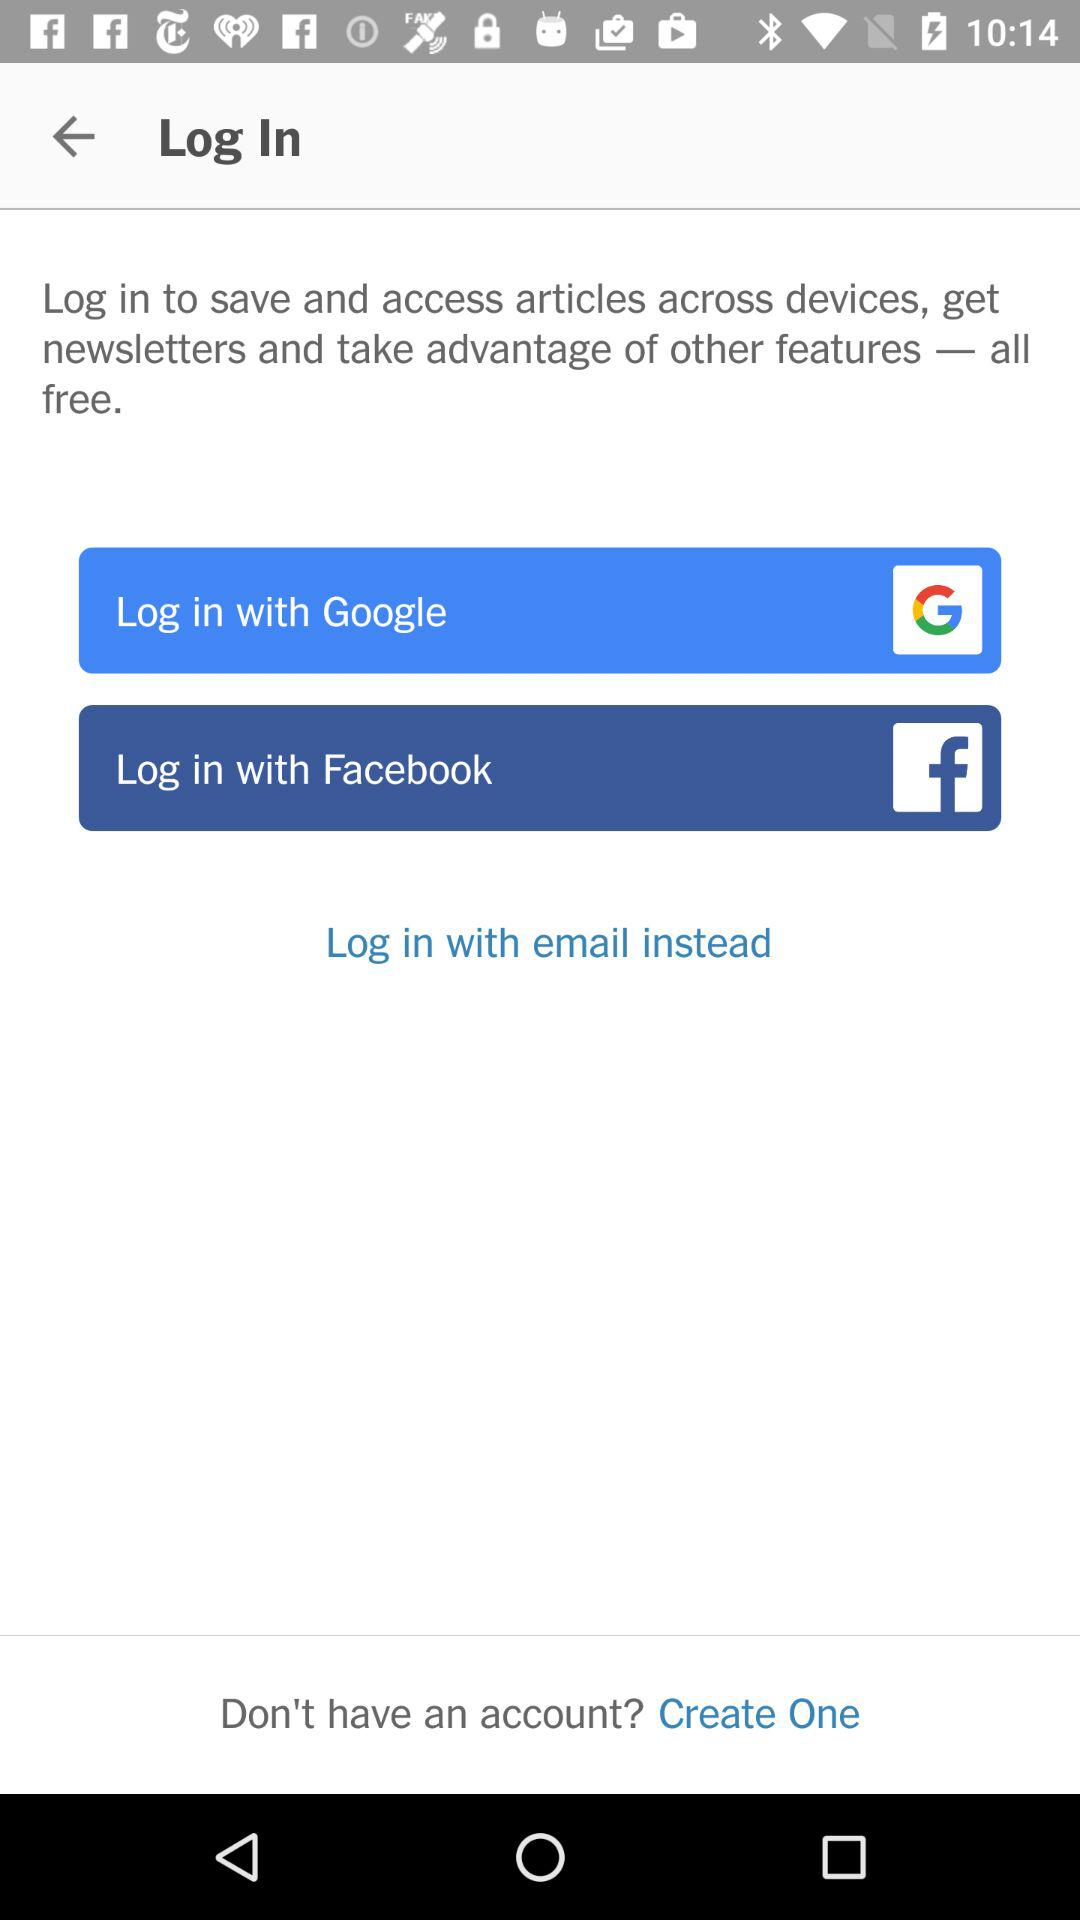Which log-in option is selected?
When the provided information is insufficient, respond with <no answer>. <no answer> 